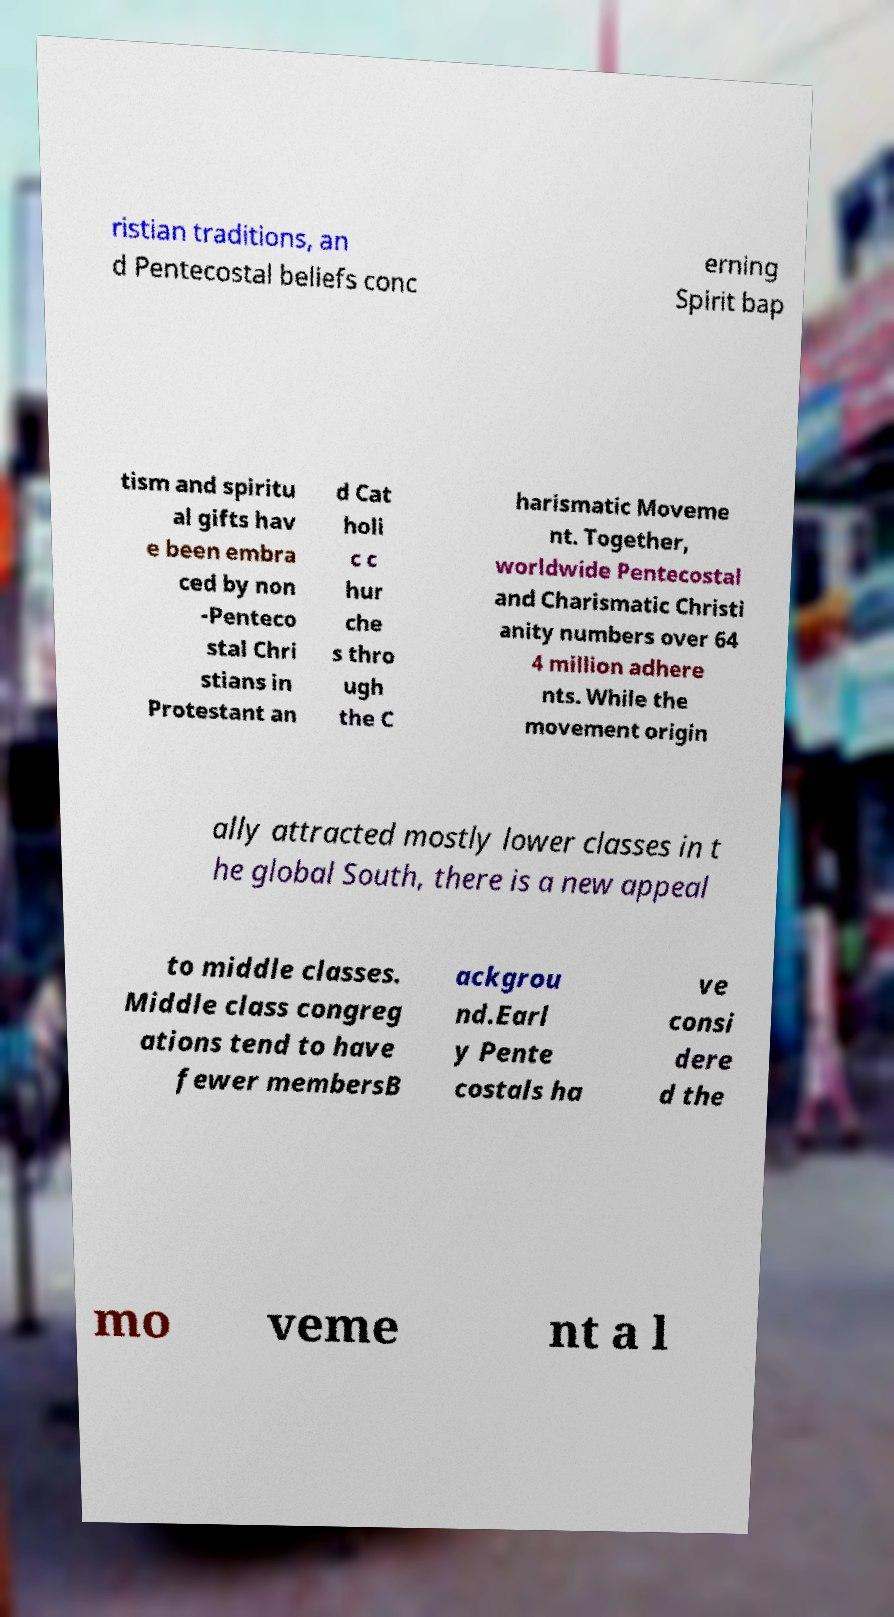Could you assist in decoding the text presented in this image and type it out clearly? ristian traditions, an d Pentecostal beliefs conc erning Spirit bap tism and spiritu al gifts hav e been embra ced by non -Penteco stal Chri stians in Protestant an d Cat holi c c hur che s thro ugh the C harismatic Moveme nt. Together, worldwide Pentecostal and Charismatic Christi anity numbers over 64 4 million adhere nts. While the movement origin ally attracted mostly lower classes in t he global South, there is a new appeal to middle classes. Middle class congreg ations tend to have fewer membersB ackgrou nd.Earl y Pente costals ha ve consi dere d the mo veme nt a l 